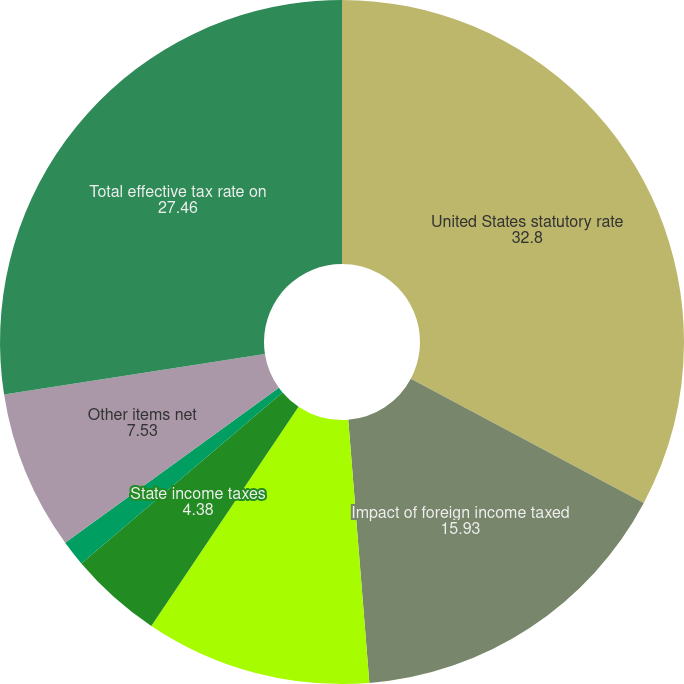Convert chart to OTSL. <chart><loc_0><loc_0><loc_500><loc_500><pie_chart><fcel>United States statutory rate<fcel>Impact of foreign income taxed<fcel>Valuation allowance against<fcel>State income taxes<fcel>Adjustments of prior year<fcel>Other items net<fcel>Total effective tax rate on<nl><fcel>32.8%<fcel>15.93%<fcel>10.69%<fcel>4.38%<fcel>1.22%<fcel>7.53%<fcel>27.46%<nl></chart> 